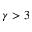<formula> <loc_0><loc_0><loc_500><loc_500>\gamma > 3</formula> 